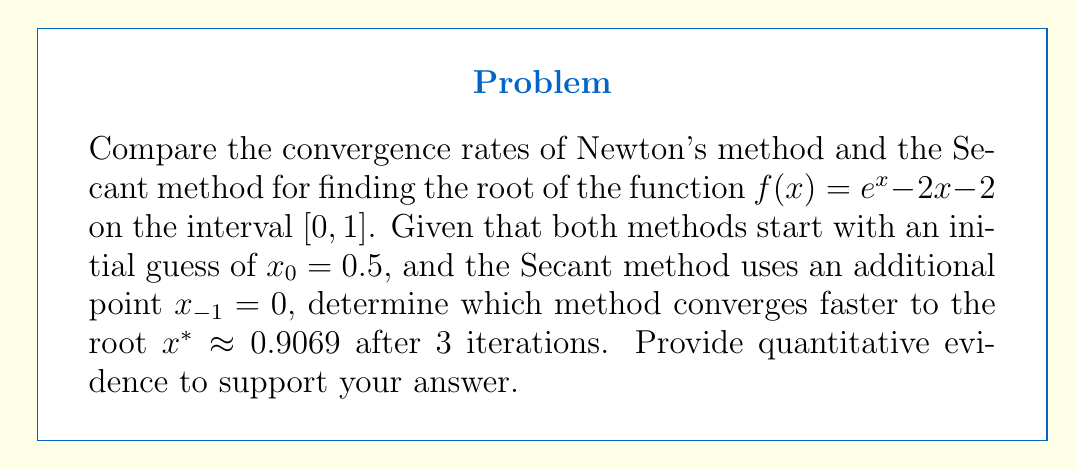Teach me how to tackle this problem. To compare the convergence rates, we'll implement both methods for 3 iterations and calculate the absolute error at each step.

Newton's Method: $x_{n+1} = x_n - \frac{f(x_n)}{f'(x_n)}$

1) First, we need $f'(x) = e^x - 2$

2) Iterate:
   $x_0 = 0.5$
   $x_1 = 0.5 - \frac{e^{0.5} - 2(0.5) - 2}{e^{0.5} - 2} \approx 0.8479$
   $x_2 = 0.8479 - \frac{e^{0.8479} - 2(0.8479) - 2}{e^{0.8479} - 2} \approx 0.9062$
   $x_3 = 0.9062 - \frac{e^{0.9062} - 2(0.9062) - 2}{e^{0.9062} - 2} \approx 0.9069$

Secant Method: $x_{n+1} = x_n - f(x_n) \frac{x_n - x_{n-1}}{f(x_n) - f(x_{n-1})}$

3) Iterate:
   $x_{-1} = 0, x_0 = 0.5$
   $x_1 = 0.5 - (e^{0.5} - 2(0.5) - 2) \frac{0.5 - 0}{(e^{0.5} - 2(0.5) - 2) - (1 - 2(0) - 2)} \approx 0.7758$
   $x_2 = 0.7758 - (e^{0.7758} - 2(0.7758) - 2) \frac{0.7758 - 0.5}{(e^{0.7758} - 2(0.7758) - 2) - (e^{0.5} - 2(0.5) - 2)} \approx 0.8971$
   $x_3 = 0.8971 - (e^{0.8971} - 2(0.8971) - 2) \frac{0.8971 - 0.7758}{(e^{0.8971} - 2(0.8971) - 2) - (e^{0.7758} - 2(0.7758) - 2)} \approx 0.9068$

4) Calculate absolute errors:

   Newton's Method:
   $|x^* - x_1| \approx 0.0590$
   $|x^* - x_2| \approx 0.0007$
   $|x^* - x_3| \approx 0.0000$

   Secant Method:
   $|x^* - x_1| \approx 0.1311$
   $|x^* - x_2| \approx 0.0098$
   $|x^* - x_3| \approx 0.0001$

5) Comparing the errors after 3 iterations, we can see that Newton's method has a smaller error ($0.0000$ vs $0.0001$), indicating faster convergence.
Answer: Newton's method converges faster, with an error of $0.0000$ vs $0.0001$ for the Secant method after 3 iterations. 